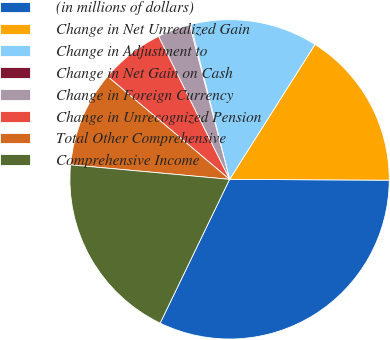Convert chart to OTSL. <chart><loc_0><loc_0><loc_500><loc_500><pie_chart><fcel>(in millions of dollars)<fcel>Change in Net Unrealized Gain<fcel>Change in Adjustment to<fcel>Change in Net Gain on Cash<fcel>Change in Foreign Currency<fcel>Change in Unrecognized Pension<fcel>Total Other Comprehensive<fcel>Comprehensive Income<nl><fcel>32.08%<fcel>16.1%<fcel>12.9%<fcel>0.11%<fcel>3.31%<fcel>6.51%<fcel>9.7%<fcel>19.29%<nl></chart> 